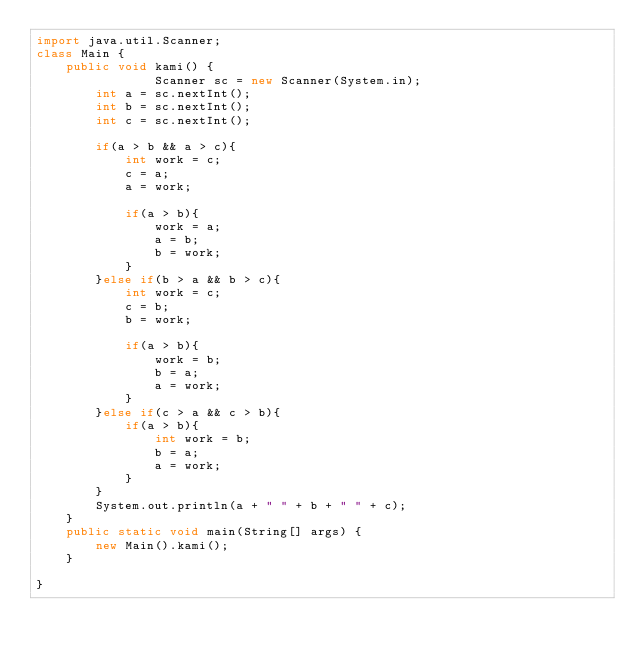Convert code to text. <code><loc_0><loc_0><loc_500><loc_500><_Java_>import java.util.Scanner;
class Main {
    public void kami() {
        		Scanner sc = new Scanner(System.in);
		int a = sc.nextInt();
		int b = sc.nextInt();
		int c = sc.nextInt();
		
		if(a > b && a > c){
			int work = c;
			c = a;
			a = work;
			
			if(a > b){
				work = a;
				a = b;
				b = work;
			}
		}else if(b > a && b > c){
			int work = c;
			c = b;
			b = work;
			
			if(a > b){
				work = b;
				b = a;
				a = work;
			}
		}else if(c > a && c > b){
			if(a > b){
				int work = b;
				b = a;
				a = work;
			}
		}
		System.out.println(a + " " + b + " " + c);
    }
	public static void main(String[] args) {
        new Main().kami();
	}

}</code> 